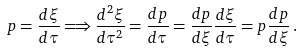Convert formula to latex. <formula><loc_0><loc_0><loc_500><loc_500>p = \frac { d \xi } { d \tau } \Longrightarrow \frac { d ^ { 2 } \xi } { d \tau ^ { 2 } } = \frac { d p } { d \tau } = \frac { d p } { d \xi } \frac { d \xi } { d \tau } = p \frac { d p } { d \xi } \, .</formula> 